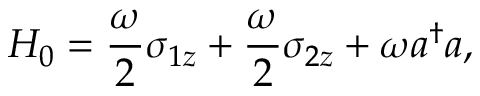Convert formula to latex. <formula><loc_0><loc_0><loc_500><loc_500>H _ { 0 } = \frac { \omega } { 2 } \sigma _ { 1 z } + \frac { \omega } { 2 } \sigma _ { 2 z } + \omega a ^ { \dagger } a ,</formula> 